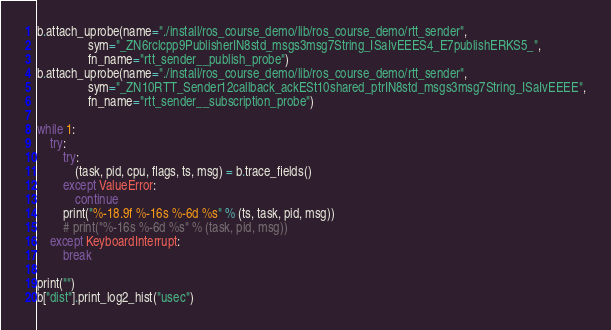Convert code to text. <code><loc_0><loc_0><loc_500><loc_500><_Python_>
b.attach_uprobe(name="./install/ros_course_demo/lib/ros_course_demo/rtt_sender",
                sym="_ZN6rclcpp9PublisherIN8std_msgs3msg7String_ISaIvEEES4_E7publishERKS5_",
                fn_name="rtt_sender__publish_probe")
b.attach_uprobe(name="./install/ros_course_demo/lib/ros_course_demo/rtt_sender",
                sym="_ZN10RTT_Sender12callback_ackESt10shared_ptrIN8std_msgs3msg7String_ISaIvEEEE",
                fn_name="rtt_sender__subscription_probe")

while 1:
    try:
        try:
            (task, pid, cpu, flags, ts, msg) = b.trace_fields()
        except ValueError:
            continue
        print("%-18.9f %-16s %-6d %s" % (ts, task, pid, msg))
        # print("%-16s %-6d %s" % (task, pid, msg))
    except KeyboardInterrupt:
        break

print("")
b["dist"].print_log2_hist("usec")</code> 